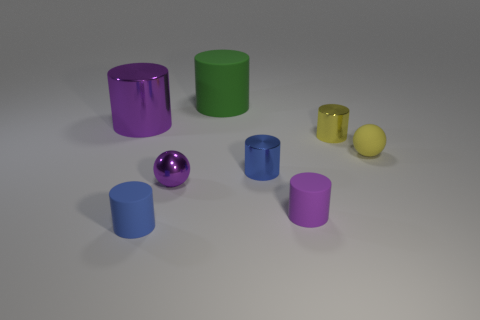Is there anything else that is the same color as the matte ball?
Your response must be concise. Yes. What shape is the metallic thing that is the same color as the shiny sphere?
Offer a terse response. Cylinder. How many small cylinders are both to the left of the yellow shiny cylinder and behind the small purple cylinder?
Your response must be concise. 1. Is there a cylinder that has the same material as the green object?
Your response must be concise. Yes. There is a shiny object that is the same color as the tiny shiny sphere; what is its size?
Your answer should be very brief. Large. What number of cylinders are either small yellow things or large rubber things?
Offer a terse response. 2. The green rubber thing is what size?
Keep it short and to the point. Large. How many small blue objects are on the right side of the blue matte object?
Your answer should be very brief. 1. What is the size of the purple metal thing behind the tiny cylinder behind the yellow rubber ball?
Provide a short and direct response. Large. Is the shape of the tiny rubber object that is right of the yellow shiny cylinder the same as the purple metallic thing that is in front of the yellow sphere?
Give a very brief answer. Yes. 